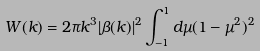<formula> <loc_0><loc_0><loc_500><loc_500>W ( k ) = 2 \pi k ^ { 3 } | \beta ( k ) | ^ { 2 } \int _ { - 1 } ^ { 1 } d \mu ( 1 - \mu ^ { 2 } ) ^ { 2 }</formula> 